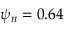<formula> <loc_0><loc_0><loc_500><loc_500>\psi _ { n } = 0 . 6 4</formula> 